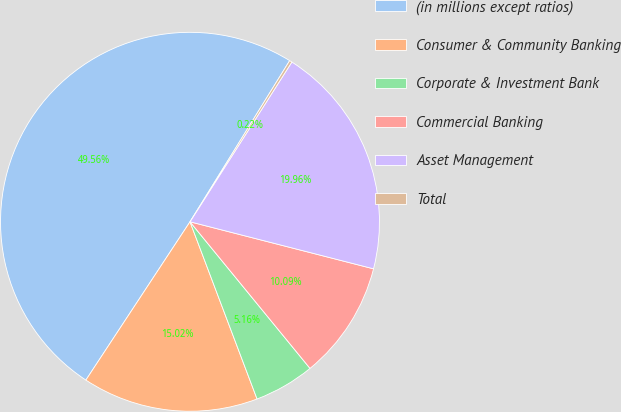<chart> <loc_0><loc_0><loc_500><loc_500><pie_chart><fcel>(in millions except ratios)<fcel>Consumer & Community Banking<fcel>Corporate & Investment Bank<fcel>Commercial Banking<fcel>Asset Management<fcel>Total<nl><fcel>49.56%<fcel>15.02%<fcel>5.16%<fcel>10.09%<fcel>19.96%<fcel>0.22%<nl></chart> 